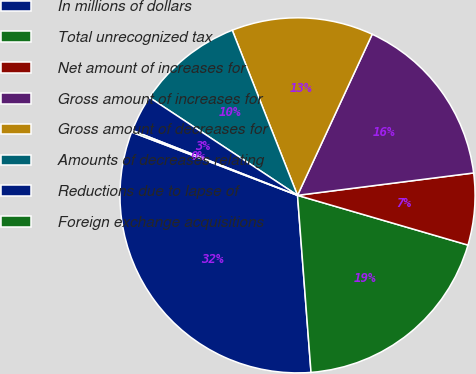<chart> <loc_0><loc_0><loc_500><loc_500><pie_chart><fcel>In millions of dollars<fcel>Total unrecognized tax<fcel>Net amount of increases for<fcel>Gross amount of increases for<fcel>Gross amount of decreases for<fcel>Amounts of decreases relating<fcel>Reductions due to lapse of<fcel>Foreign exchange acquisitions<nl><fcel>32.01%<fcel>19.27%<fcel>6.53%<fcel>16.08%<fcel>12.9%<fcel>9.71%<fcel>3.34%<fcel>0.16%<nl></chart> 